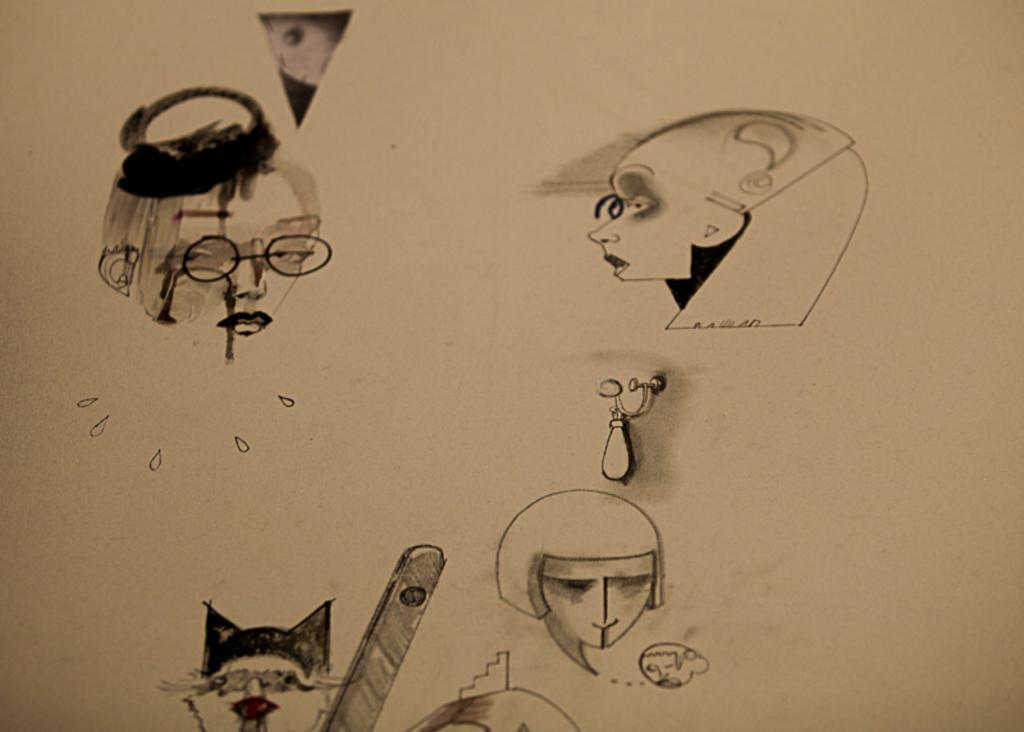Can you describe this image briefly? In this picture there are sketches of people and objects. At the back there is a cream color background. 